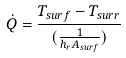Convert formula to latex. <formula><loc_0><loc_0><loc_500><loc_500>\dot { Q } = \frac { T _ { s u r f } - T _ { s u r r } } { ( \frac { 1 } { h _ { r } A _ { s u r f } } ) }</formula> 